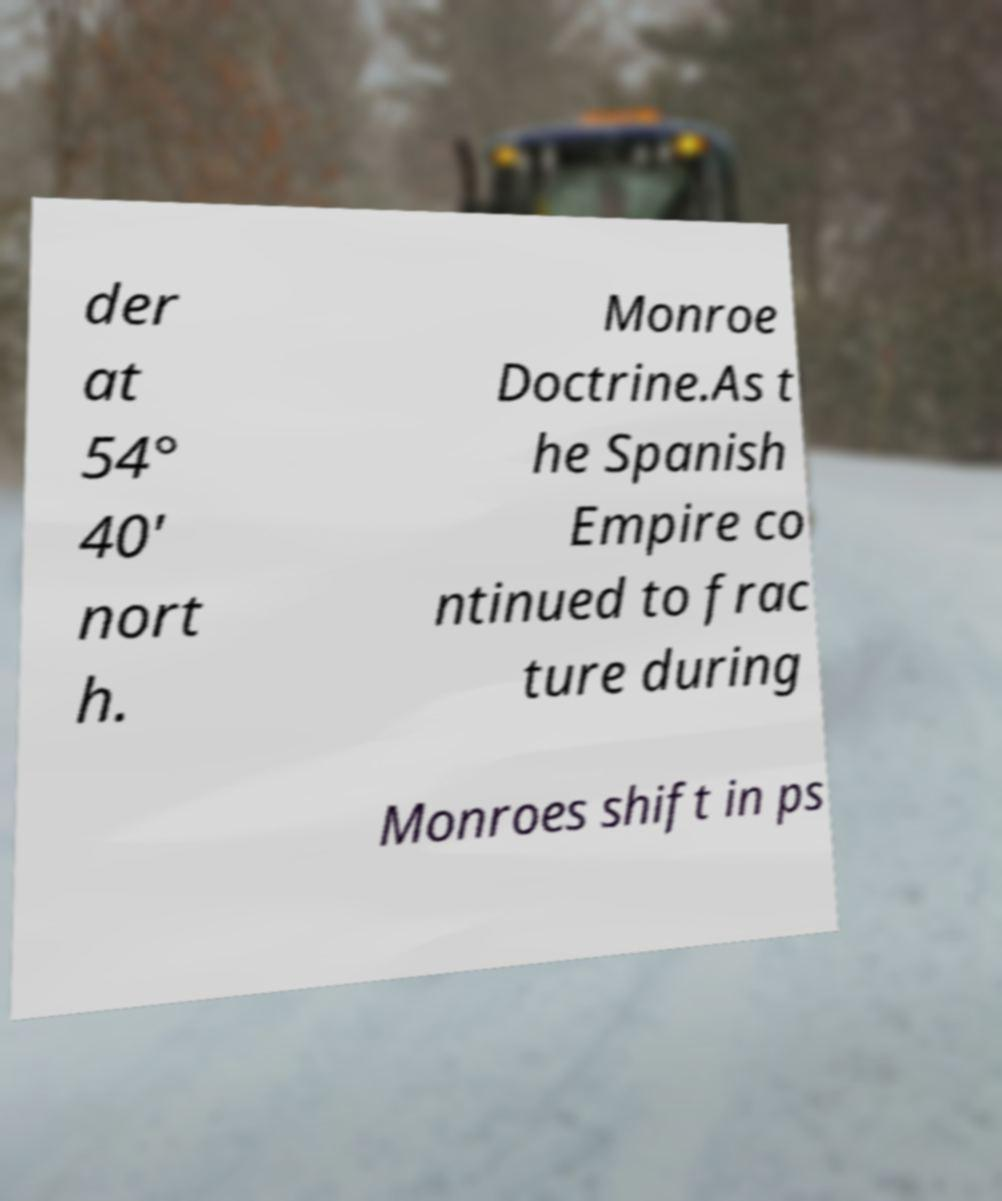There's text embedded in this image that I need extracted. Can you transcribe it verbatim? der at 54° 40′ nort h. Monroe Doctrine.As t he Spanish Empire co ntinued to frac ture during Monroes shift in ps 